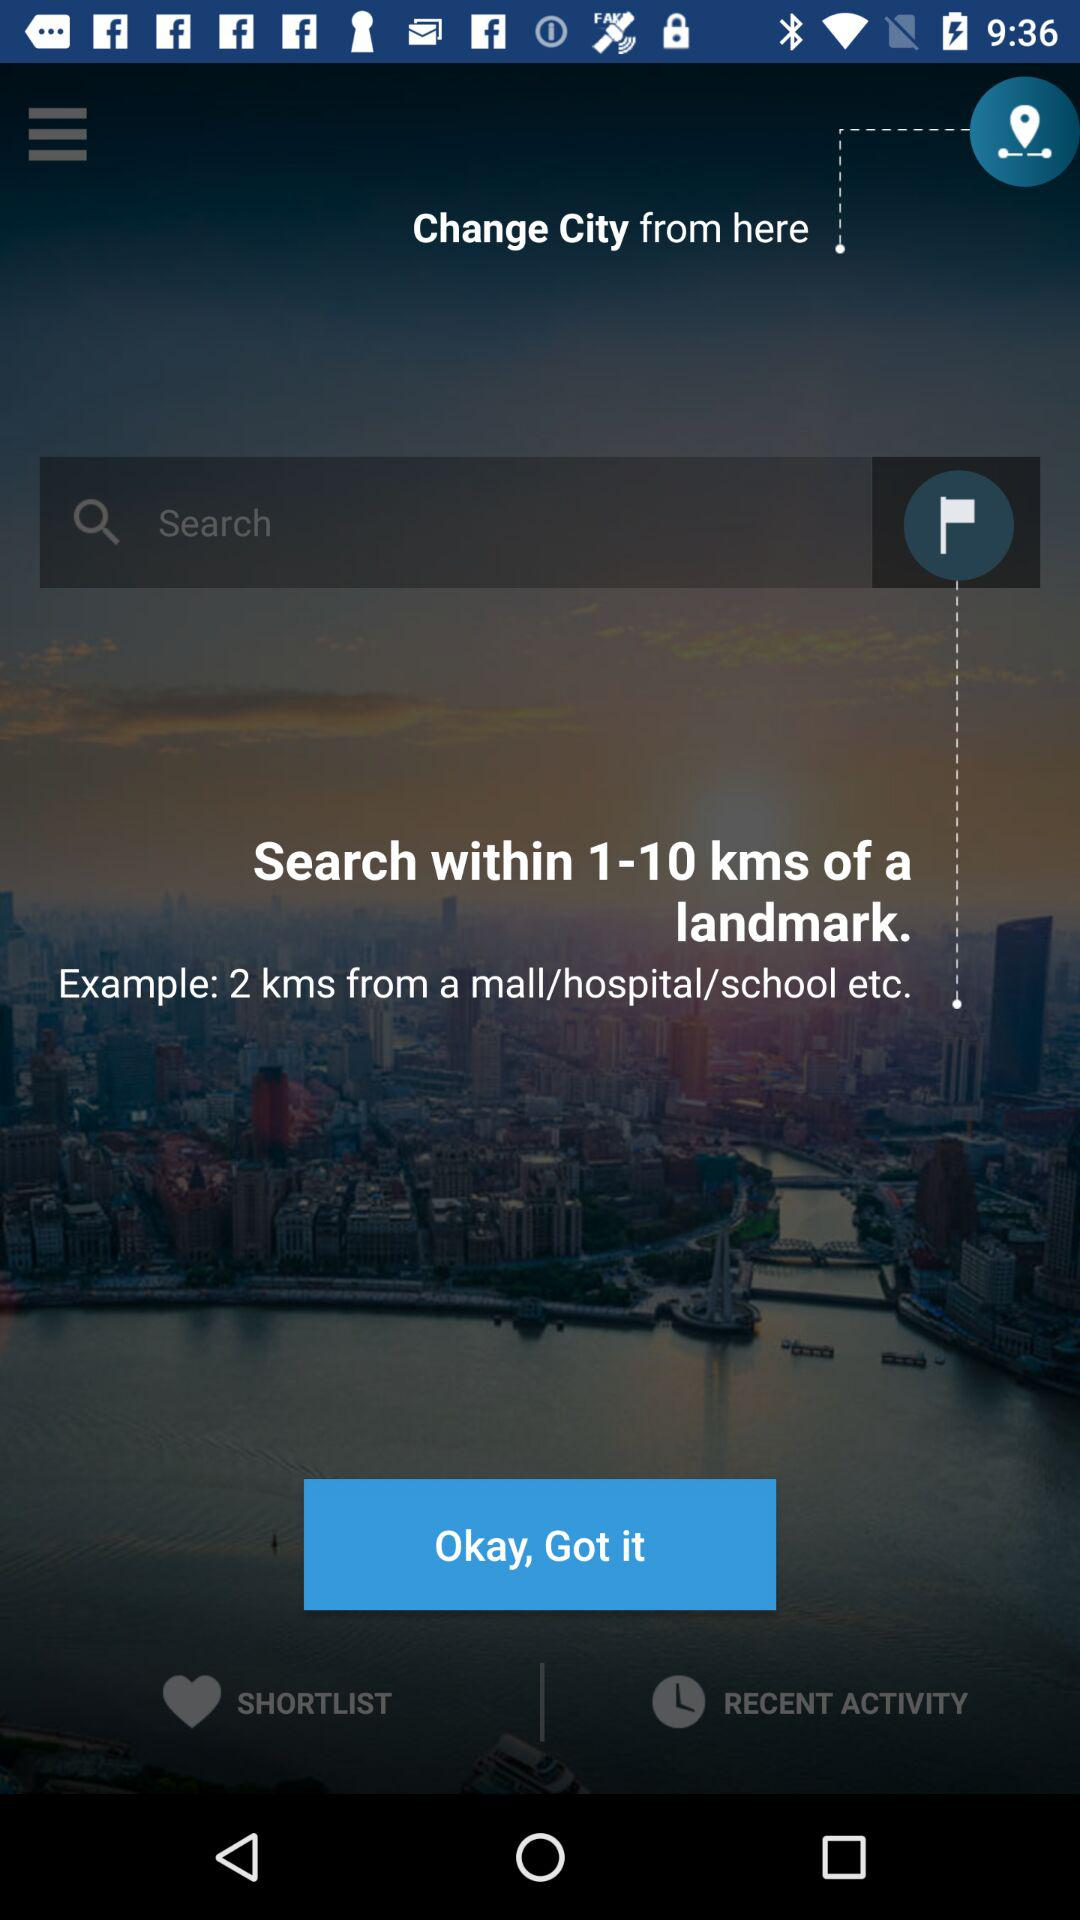How many kms does the search radius go up to?
Answer the question using a single word or phrase. 10 